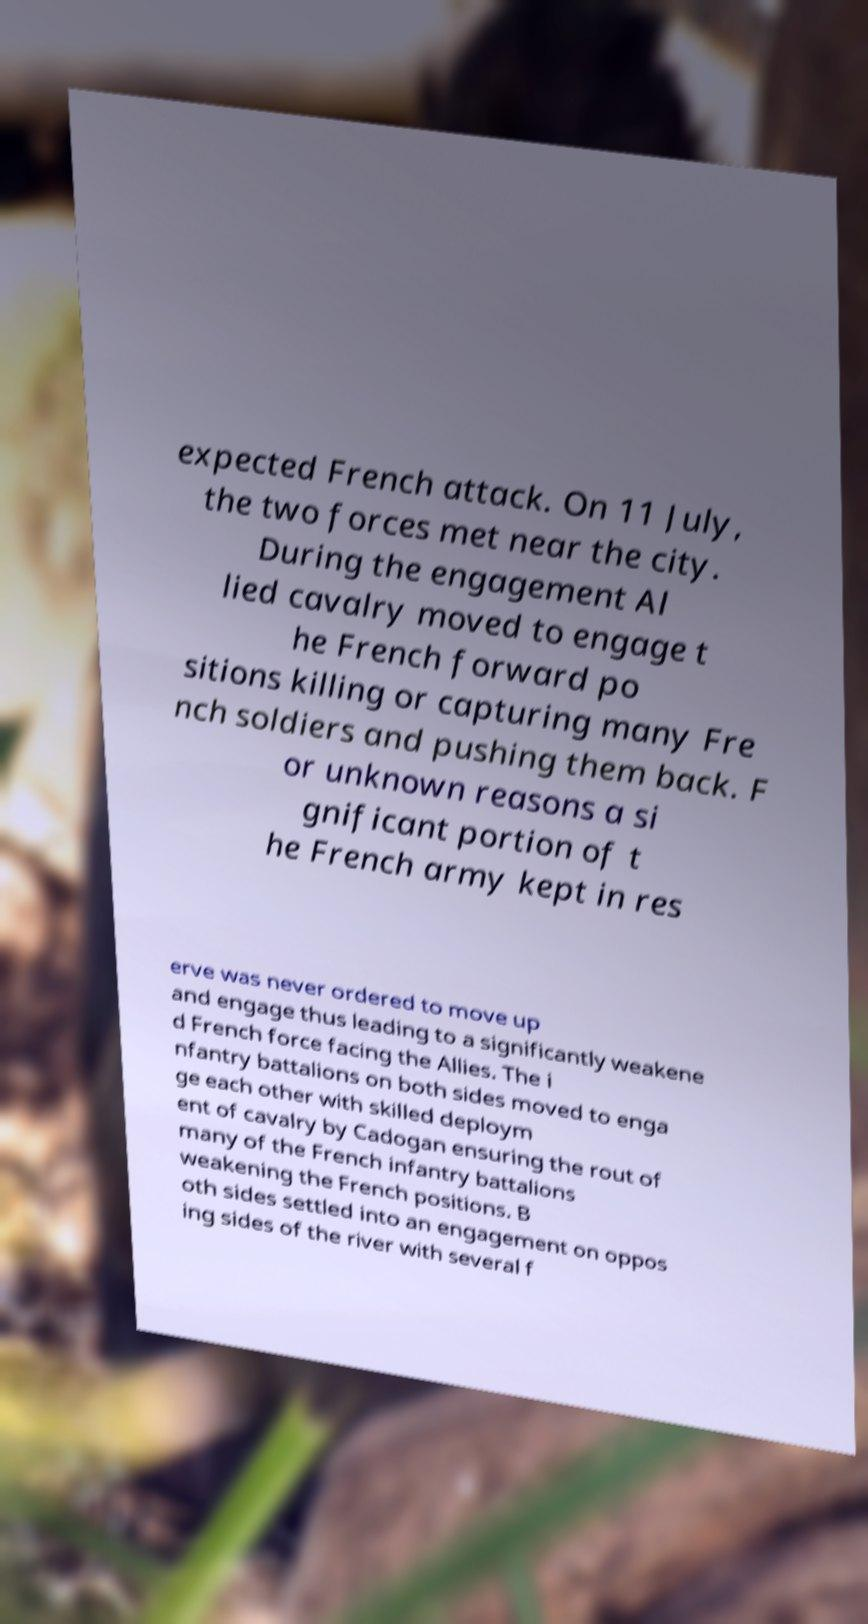Can you read and provide the text displayed in the image?This photo seems to have some interesting text. Can you extract and type it out for me? expected French attack. On 11 July, the two forces met near the city. During the engagement Al lied cavalry moved to engage t he French forward po sitions killing or capturing many Fre nch soldiers and pushing them back. F or unknown reasons a si gnificant portion of t he French army kept in res erve was never ordered to move up and engage thus leading to a significantly weakene d French force facing the Allies. The i nfantry battalions on both sides moved to enga ge each other with skilled deploym ent of cavalry by Cadogan ensuring the rout of many of the French infantry battalions weakening the French positions. B oth sides settled into an engagement on oppos ing sides of the river with several f 